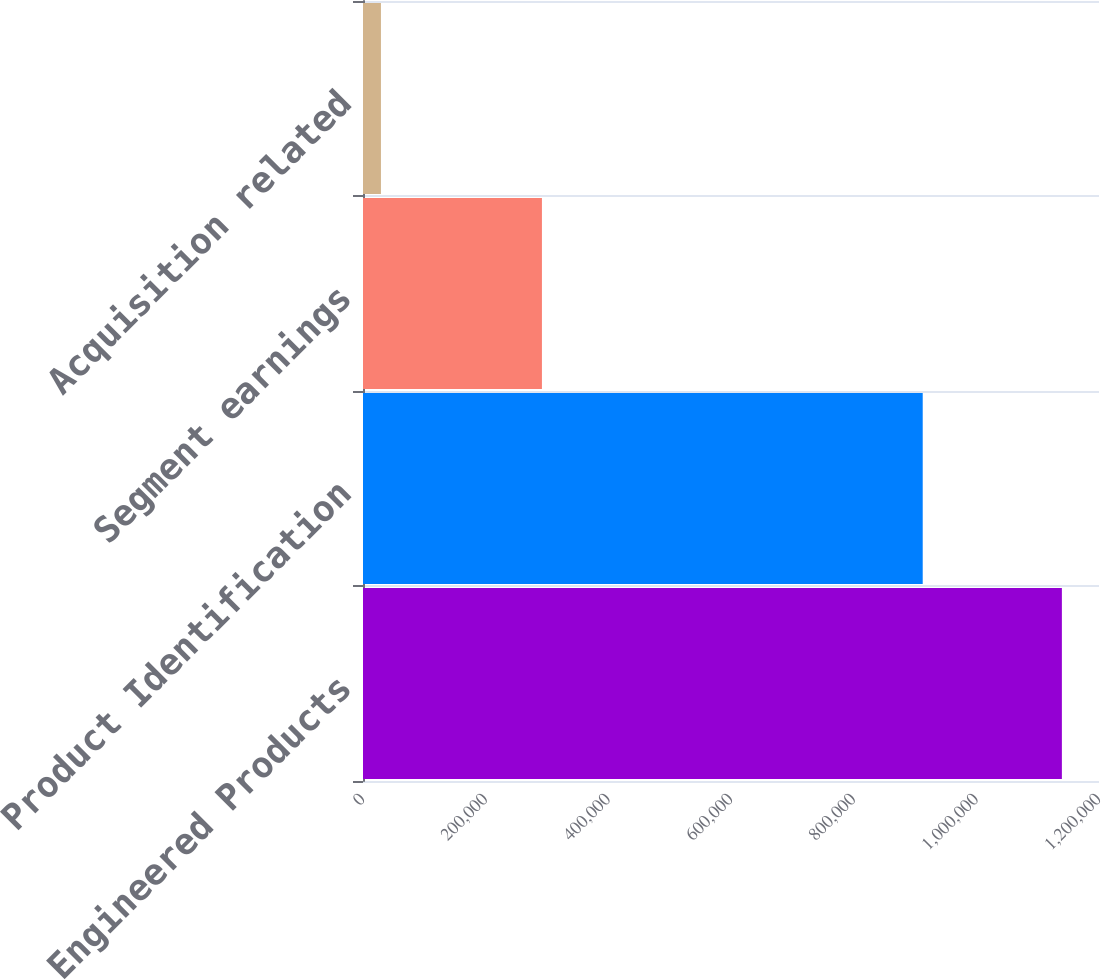Convert chart to OTSL. <chart><loc_0><loc_0><loc_500><loc_500><bar_chart><fcel>Engineered Products<fcel>Product Identification<fcel>Segment earnings<fcel>Acquisition related<nl><fcel>1.13948e+06<fcel>912580<fcel>291727<fcel>29262<nl></chart> 